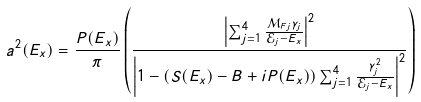<formula> <loc_0><loc_0><loc_500><loc_500>a ^ { 2 } ( E _ { x } ) = \frac { P ( E _ { x } ) } { \pi } \left ( \frac { \left | \sum _ { j = 1 } ^ { 4 } \frac { \mathcal { M } _ { F j } \gamma _ { j } } { \mathcal { E } _ { j } - E _ { x } } \right | ^ { 2 } } { \left | 1 - \left ( S ( E _ { x } ) - B + i P ( E _ { x } ) \right ) \sum _ { j = 1 } ^ { 4 } \frac { \gamma _ { j } ^ { 2 } } { \mathcal { E } _ { j } - E _ { x } } \right | ^ { 2 } } \right )</formula> 